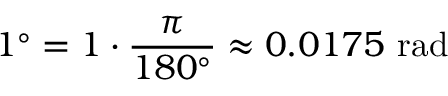Convert formula to latex. <formula><loc_0><loc_0><loc_500><loc_500>1 ^ { \circ } = 1 \cdot { \frac { \pi } { 1 8 0 ^ { \circ } } } \approx 0 . 0 1 7 5 { r a d }</formula> 